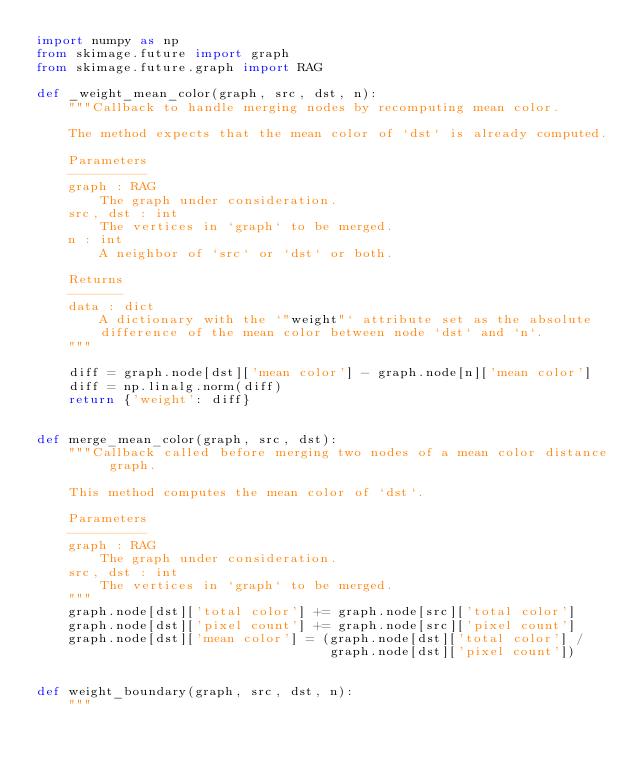Convert code to text. <code><loc_0><loc_0><loc_500><loc_500><_Python_>import numpy as np
from skimage.future import graph
from skimage.future.graph import RAG

def _weight_mean_color(graph, src, dst, n):
    """Callback to handle merging nodes by recomputing mean color.

    The method expects that the mean color of `dst` is already computed.

    Parameters
    ----------
    graph : RAG
        The graph under consideration.
    src, dst : int
        The vertices in `graph` to be merged.
    n : int
        A neighbor of `src` or `dst` or both.

    Returns
    -------
    data : dict
        A dictionary with the `"weight"` attribute set as the absolute
        difference of the mean color between node `dst` and `n`.
    """

    diff = graph.node[dst]['mean color'] - graph.node[n]['mean color']
    diff = np.linalg.norm(diff)
    return {'weight': diff}


def merge_mean_color(graph, src, dst):
    """Callback called before merging two nodes of a mean color distance graph.

    This method computes the mean color of `dst`.

    Parameters
    ----------
    graph : RAG
        The graph under consideration.
    src, dst : int
        The vertices in `graph` to be merged.
    """
    graph.node[dst]['total color'] += graph.node[src]['total color']
    graph.node[dst]['pixel count'] += graph.node[src]['pixel count']
    graph.node[dst]['mean color'] = (graph.node[dst]['total color'] /
                                     graph.node[dst]['pixel count'])


def weight_boundary(graph, src, dst, n):
    """</code> 